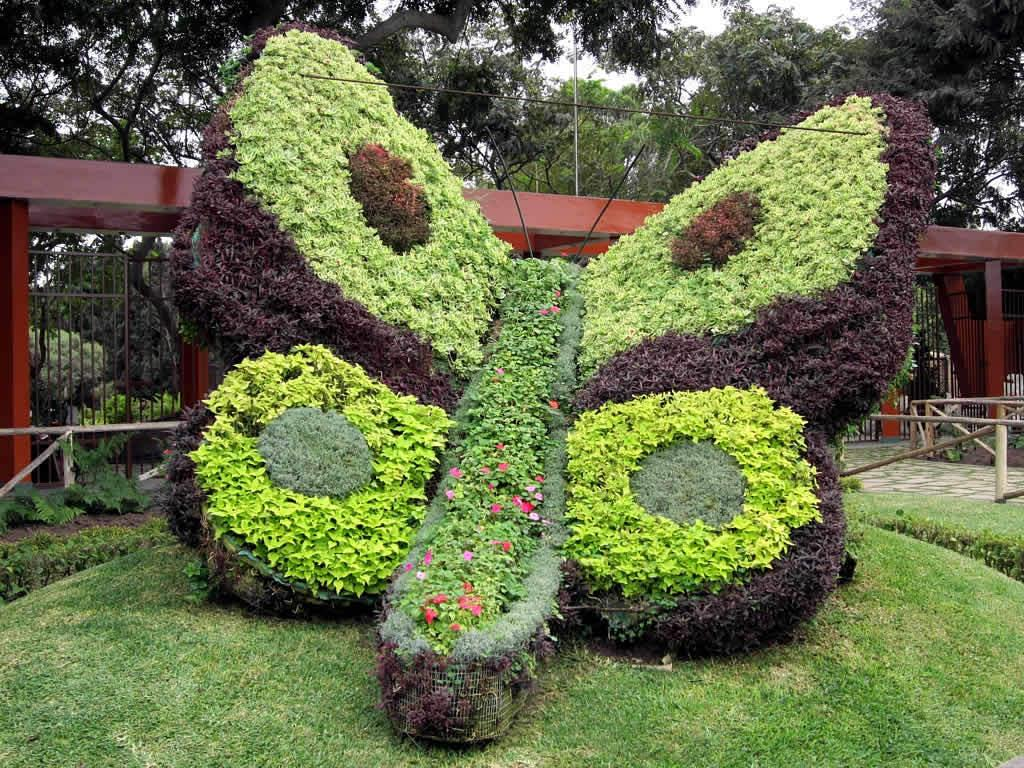What is the shape of the plants in the image? The plants in the image are in the shape of a butterfly. What can be seen in the background of the image? There is a railing, a shed, many trees, and the sky visible in the background of the image. What type of coal is being used to fuel the instrument in the image? There is no coal or instrument present in the image. What type of beef is being served at the table in the image? There is no table or beef present in the image. 